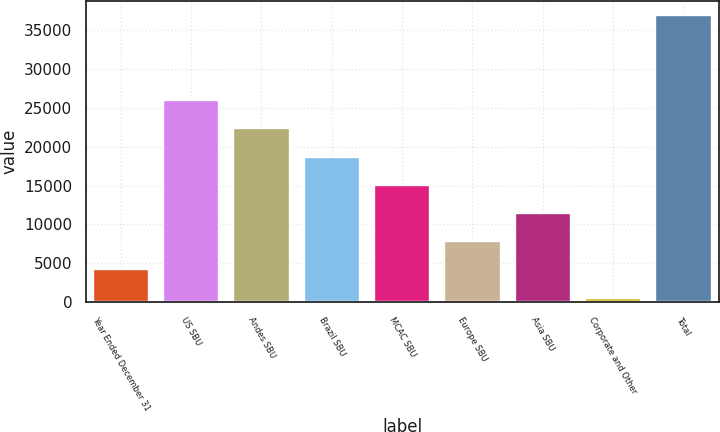Convert chart to OTSL. <chart><loc_0><loc_0><loc_500><loc_500><bar_chart><fcel>Year Ended December 31<fcel>US SBU<fcel>Andes SBU<fcel>Brazil SBU<fcel>MCAC SBU<fcel>Europe SBU<fcel>Asia SBU<fcel>Corporate and Other<fcel>Total<nl><fcel>4216<fcel>25972<fcel>22346<fcel>18720<fcel>15094<fcel>7842<fcel>11468<fcel>590<fcel>36850<nl></chart> 